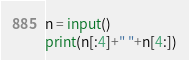Convert code to text. <code><loc_0><loc_0><loc_500><loc_500><_Python_>n = input()
print(n[:4]+" "+n[4:])</code> 